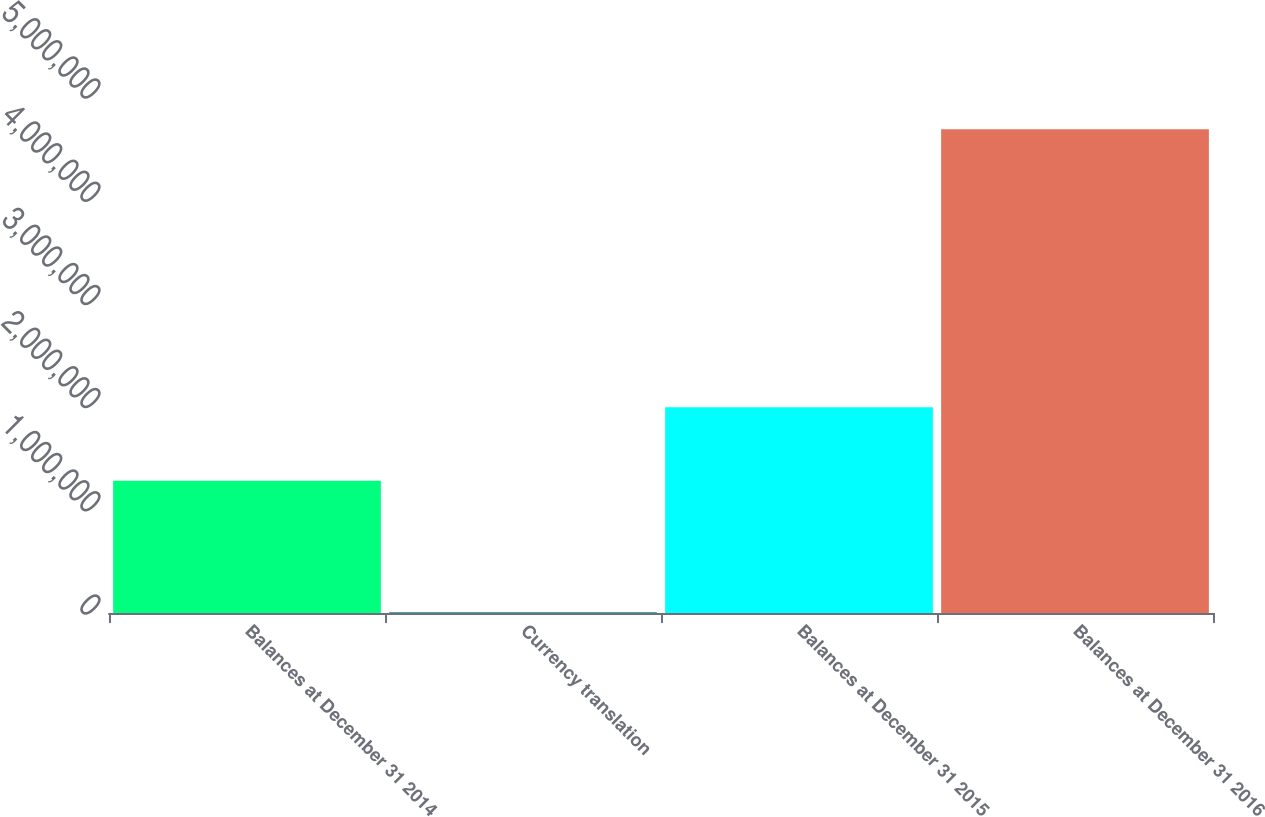<chart> <loc_0><loc_0><loc_500><loc_500><bar_chart><fcel>Balances at December 31 2014<fcel>Currency translation<fcel>Balances at December 31 2015<fcel>Balances at December 31 2016<nl><fcel>1.28079e+06<fcel>7667<fcel>1.9933e+06<fcel>4.68767e+06<nl></chart> 